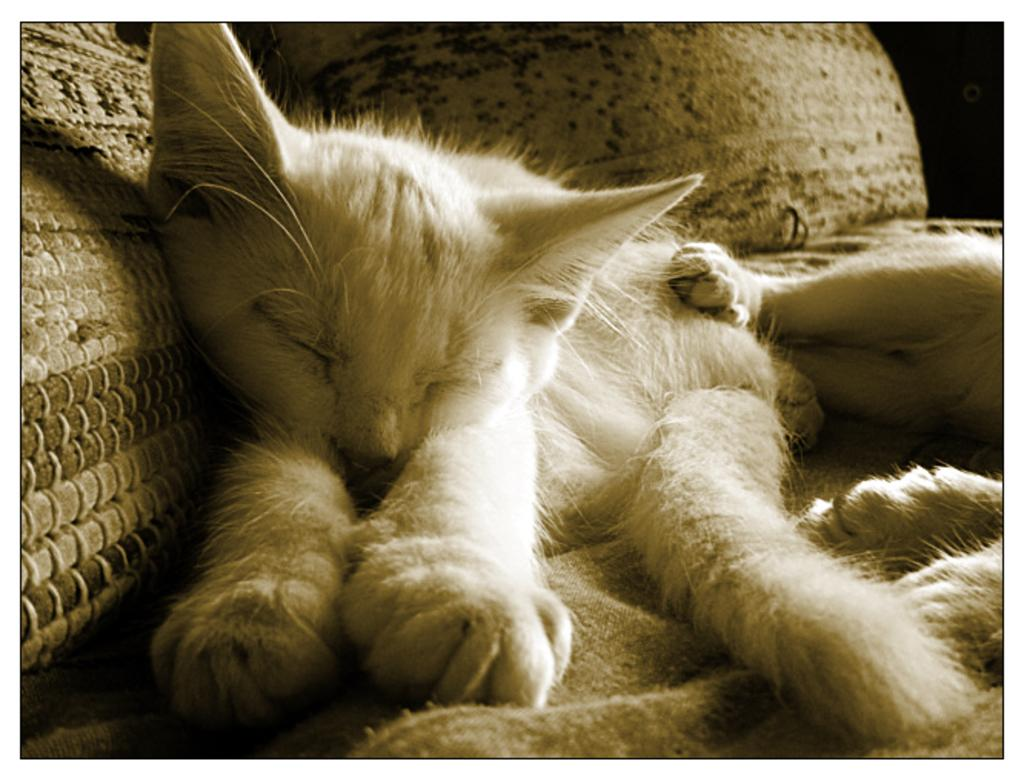What animals are present in the image? There are two cats in the image. Where are the cats located in the image? The cats are in the middle of the image. What can be seen in the background of the image? There are pillows in the background of the image. What is the taste of the cats in the image? Cats do not have a taste, as they are animals and not food items. 